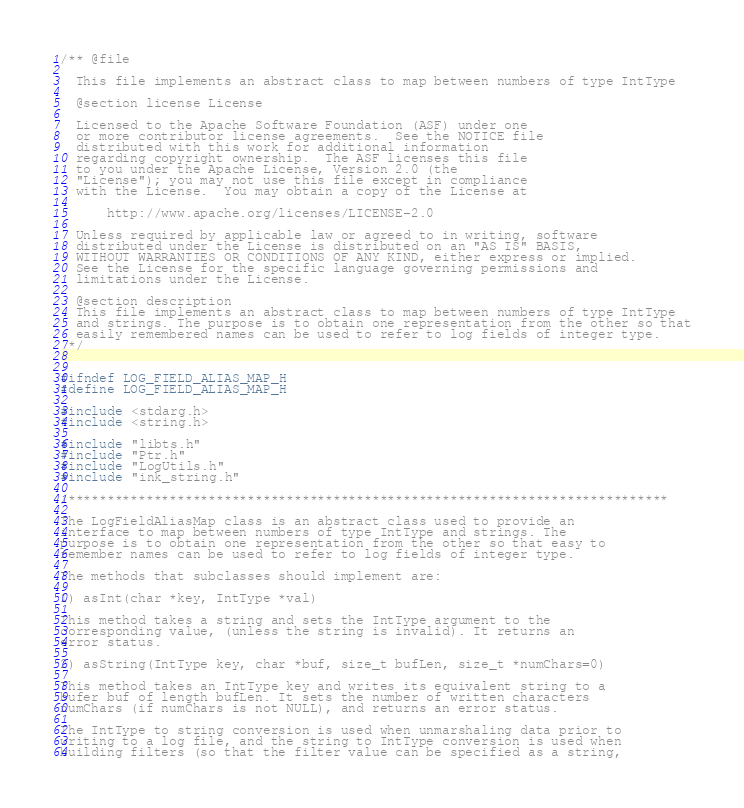<code> <loc_0><loc_0><loc_500><loc_500><_C_>/** @file

  This file implements an abstract class to map between numbers of type IntType

  @section license License

  Licensed to the Apache Software Foundation (ASF) under one
  or more contributor license agreements.  See the NOTICE file
  distributed with this work for additional information
  regarding copyright ownership.  The ASF licenses this file
  to you under the Apache License, Version 2.0 (the
  "License"); you may not use this file except in compliance
  with the License.  You may obtain a copy of the License at

      http://www.apache.org/licenses/LICENSE-2.0

  Unless required by applicable law or agreed to in writing, software
  distributed under the License is distributed on an "AS IS" BASIS,
  WITHOUT WARRANTIES OR CONDITIONS OF ANY KIND, either express or implied.
  See the License for the specific language governing permissions and
  limitations under the License.

  @section description
  This file implements an abstract class to map between numbers of type IntType
  and strings. The purpose is to obtain one representation from the other so that
  easily remembered names can be used to refer to log fields of integer type.
 */


#ifndef LOG_FIELD_ALIAS_MAP_H
#define LOG_FIELD_ALIAS_MAP_H

#include <stdarg.h>
#include <string.h>

#include "libts.h"
#include "Ptr.h"
#include "LogUtils.h"
#include "ink_string.h"

/*****************************************************************************

The LogFieldAliasMap class is an abstract class used to provide an
interface to map between numbers of type IntType and strings. The
purpose is to obtain one representation from the other so that easy to
remember names can be used to refer to log fields of integer type.

The methods that subclasses should implement are:

1) asInt(char *key, IntType *val)

This method takes a string and sets the IntType argument to the
corresponding value, (unless the string is invalid). It returns an
error status.

2) asString(IntType key, char *buf, size_t bufLen, size_t *numChars=0)

This method takes an IntType key and writes its equivalent string to a
bufer buf of length bufLen. It sets the number of written characters
numChars (if numChars is not NULL), and returns an error status.

The IntType to string conversion is used when unmarshaling data prior to
writing to a log file, and the string to IntType conversion is used when
building filters (so that the filter value can be specified as a string,</code> 